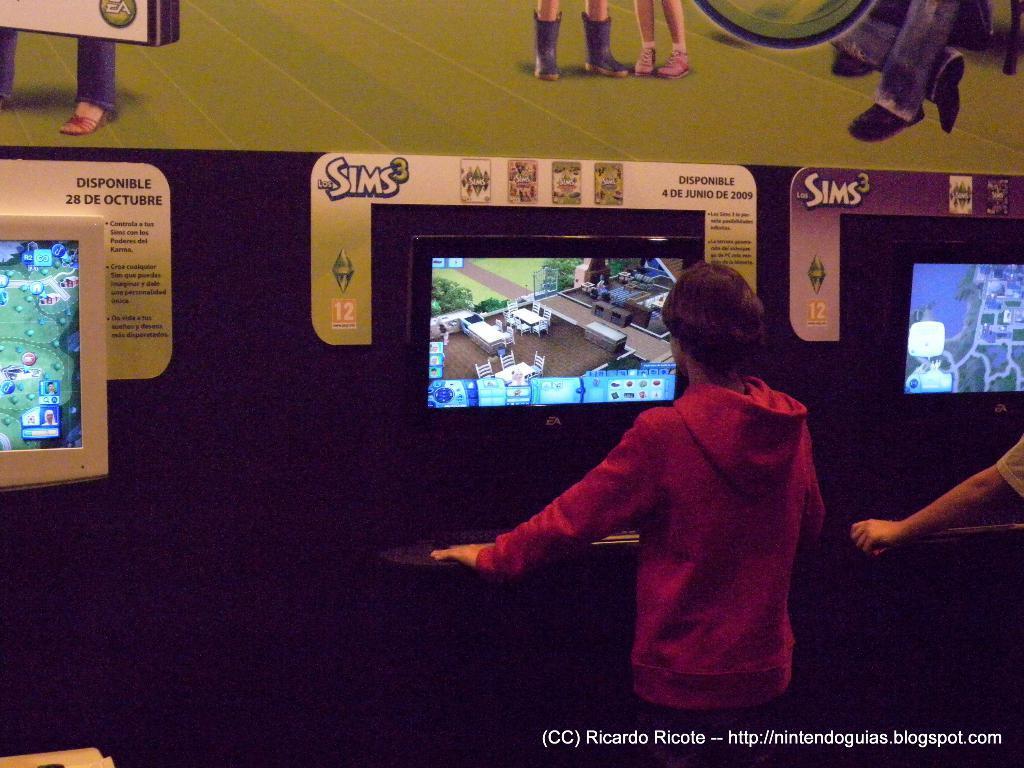Could you give a brief overview of what you see in this image? In this picture I can see few people are standing in front of the screen and playing game. 